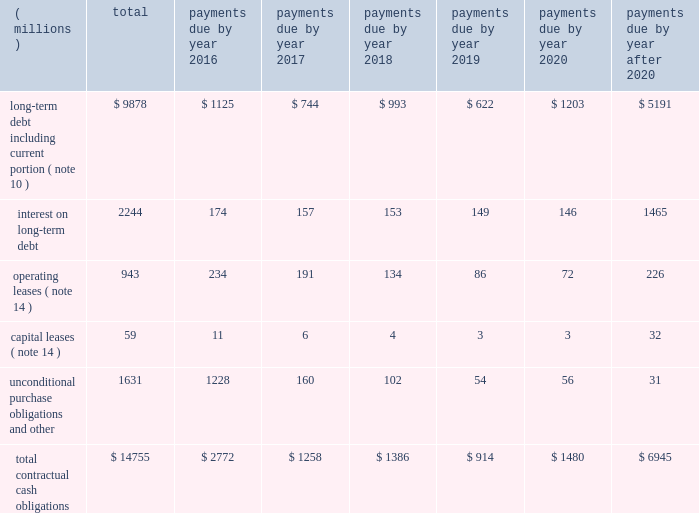A summary of the company 2019s significant contractual obligations as of december 31 , 2015 , follows : contractual obligations .
Long-term debt payments due in 2016 and 2017 include floating rate notes totaling $ 126 million ( classified as current portion of long-term debt ) , and $ 96 million ( included as a separate floating rate note in the long-term debt table ) , respectively , as a result of put provisions associated with these debt instruments .
Interest projections on both floating and fixed rate long-term debt , including the effects of interest rate swaps , are based on effective interest rates as of december 31 , 2015 .
Unconditional purchase obligations are defined as an agreement to purchase goods or services that is enforceable and legally binding on the company .
Included in the unconditional purchase obligations category above are certain obligations related to take or pay contracts , capital commitments , service agreements and utilities .
These estimates include both unconditional purchase obligations with terms in excess of one year and normal ongoing purchase obligations with terms of less than one year .
Many of these commitments relate to take or pay contracts , in which 3m guarantees payment to ensure availability of products or services that are sold to customers .
The company expects to receive consideration ( products or services ) for these unconditional purchase obligations .
Contractual capital commitments are included in the preceding table , but these commitments represent a small part of the company 2019s expected capital spending in 2016 and beyond .
The purchase obligation amounts do not represent the entire anticipated purchases in the future , but represent only those items for which the company is contractually obligated .
The majority of 3m 2019s products and services are purchased as needed , with no unconditional commitment .
For this reason , these amounts will not provide a reliable indicator of the company 2019s expected future cash outflows on a stand-alone basis .
Other obligations , included in the preceding table within the caption entitled 201cunconditional purchase obligations and other , 201d include the current portion of the liability for uncertain tax positions under asc 740 , which is expected to be paid out in cash in the next 12 months .
The company is not able to reasonably estimate the timing of the long-term payments or the amount by which the liability will increase or decrease over time ; therefore , the long-term portion of the net tax liability of $ 208 million is excluded from the preceding table .
Refer to note 8 for further details .
As discussed in note 11 , the company does not have a required minimum cash pension contribution obligation for its u.s .
Plans in 2016 and company contributions to its u.s .
And international pension plans are expected to be largely discretionary in future years ; therefore , amounts related to these plans are not included in the preceding table .
Financial instruments the company enters into foreign exchange forward contracts , options and swaps to hedge against the effect of exchange rate fluctuations on cash flows denominated in foreign currencies and certain intercompany financing transactions .
The company manages interest rate risks using a mix of fixed and floating rate debt .
To help manage borrowing costs , the company may enter into interest rate swaps .
Under these arrangements , the company agrees to exchange , at specified intervals , the difference between fixed and floating interest amounts calculated by reference to an agreed-upon notional principal amount .
The company manages commodity price risks through negotiated supply contracts , price protection agreements and forward contracts. .
What was the ratio of the floating rate notes included in the long-term debt payments due in 2016 to 2017? 
Rationale: in 2016 there was $ 1.31 floating rate notes included in the long-term debt payment compared to 2017
Computations: (126 / 96)
Answer: 1.3125. 